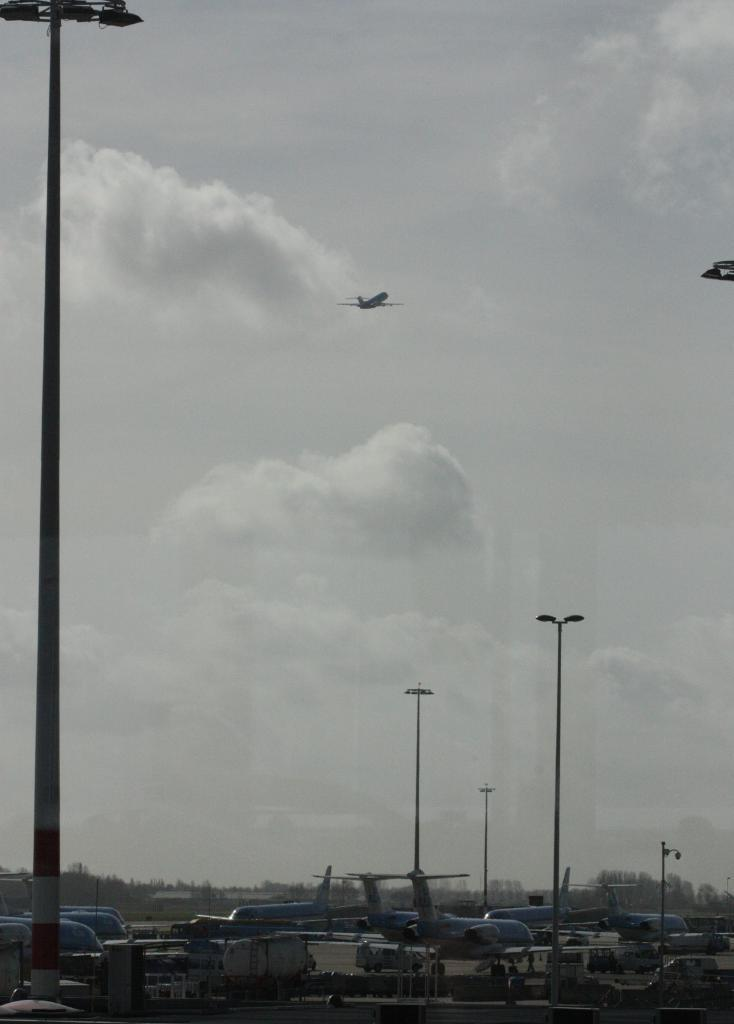What can be seen on the runway road in the image? There are aeroplanes parked on the runway road in the image. What is happening in the sky in the image? There is an aeroplane in the sky in the image. What type of infrastructure is present in the image? There are street light poles in the image. How many trees are visible on the island in the image? There is no island or tree present in the image. What is the value of the dime on the runway road in the image? There is no dime present in the image. 